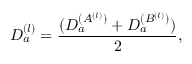Convert formula to latex. <formula><loc_0><loc_0><loc_500><loc_500>D _ { a } ^ { ( l ) } = { \frac { ( D _ { a } ^ { ( A ^ { ( l ) } ) } + D _ { a } ^ { ( B ^ { ( l ) } ) } ) } { 2 } } ,</formula> 